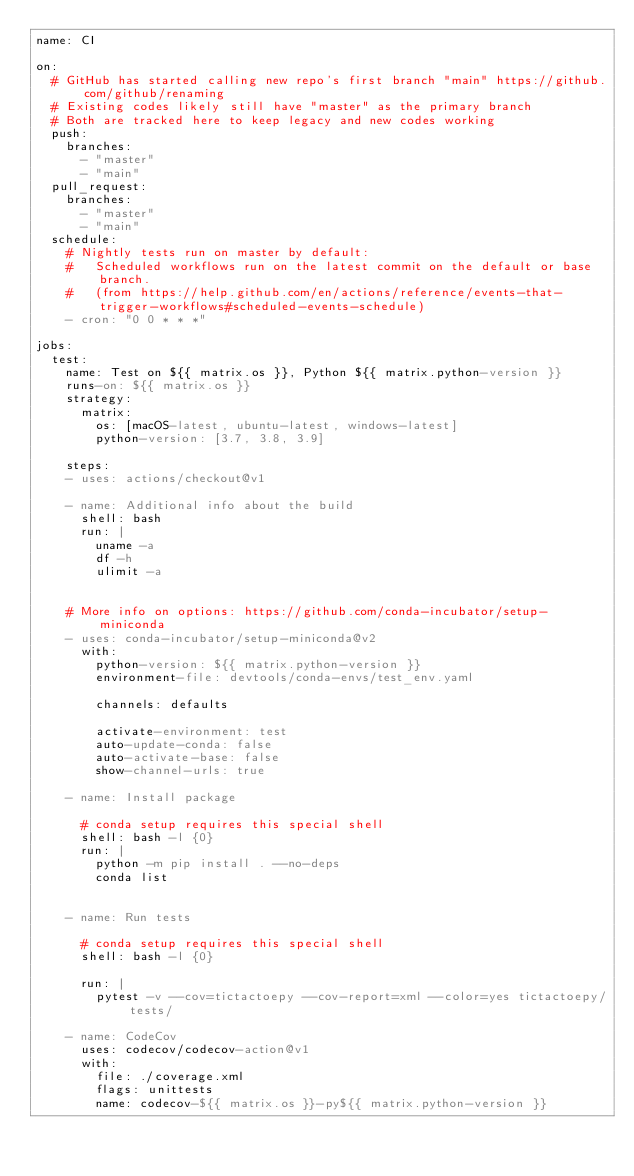<code> <loc_0><loc_0><loc_500><loc_500><_YAML_>name: CI

on:
  # GitHub has started calling new repo's first branch "main" https://github.com/github/renaming
  # Existing codes likely still have "master" as the primary branch
  # Both are tracked here to keep legacy and new codes working
  push:
    branches:
      - "master"
      - "main"
  pull_request:
    branches:
      - "master"
      - "main"
  schedule:
    # Nightly tests run on master by default:
    #   Scheduled workflows run on the latest commit on the default or base branch.
    #   (from https://help.github.com/en/actions/reference/events-that-trigger-workflows#scheduled-events-schedule)
    - cron: "0 0 * * *"

jobs:
  test:
    name: Test on ${{ matrix.os }}, Python ${{ matrix.python-version }}
    runs-on: ${{ matrix.os }}
    strategy:
      matrix:
        os: [macOS-latest, ubuntu-latest, windows-latest]
        python-version: [3.7, 3.8, 3.9]

    steps:
    - uses: actions/checkout@v1

    - name: Additional info about the build
      shell: bash
      run: |
        uname -a
        df -h
        ulimit -a


    # More info on options: https://github.com/conda-incubator/setup-miniconda
    - uses: conda-incubator/setup-miniconda@v2
      with:
        python-version: ${{ matrix.python-version }}
        environment-file: devtools/conda-envs/test_env.yaml

        channels: defaults

        activate-environment: test
        auto-update-conda: false
        auto-activate-base: false
        show-channel-urls: true

    - name: Install package

      # conda setup requires this special shell
      shell: bash -l {0}
      run: |
        python -m pip install . --no-deps
        conda list


    - name: Run tests

      # conda setup requires this special shell
      shell: bash -l {0}

      run: |
        pytest -v --cov=tictactoepy --cov-report=xml --color=yes tictactoepy/tests/

    - name: CodeCov
      uses: codecov/codecov-action@v1
      with:
        file: ./coverage.xml
        flags: unittests
        name: codecov-${{ matrix.os }}-py${{ matrix.python-version }}
</code> 